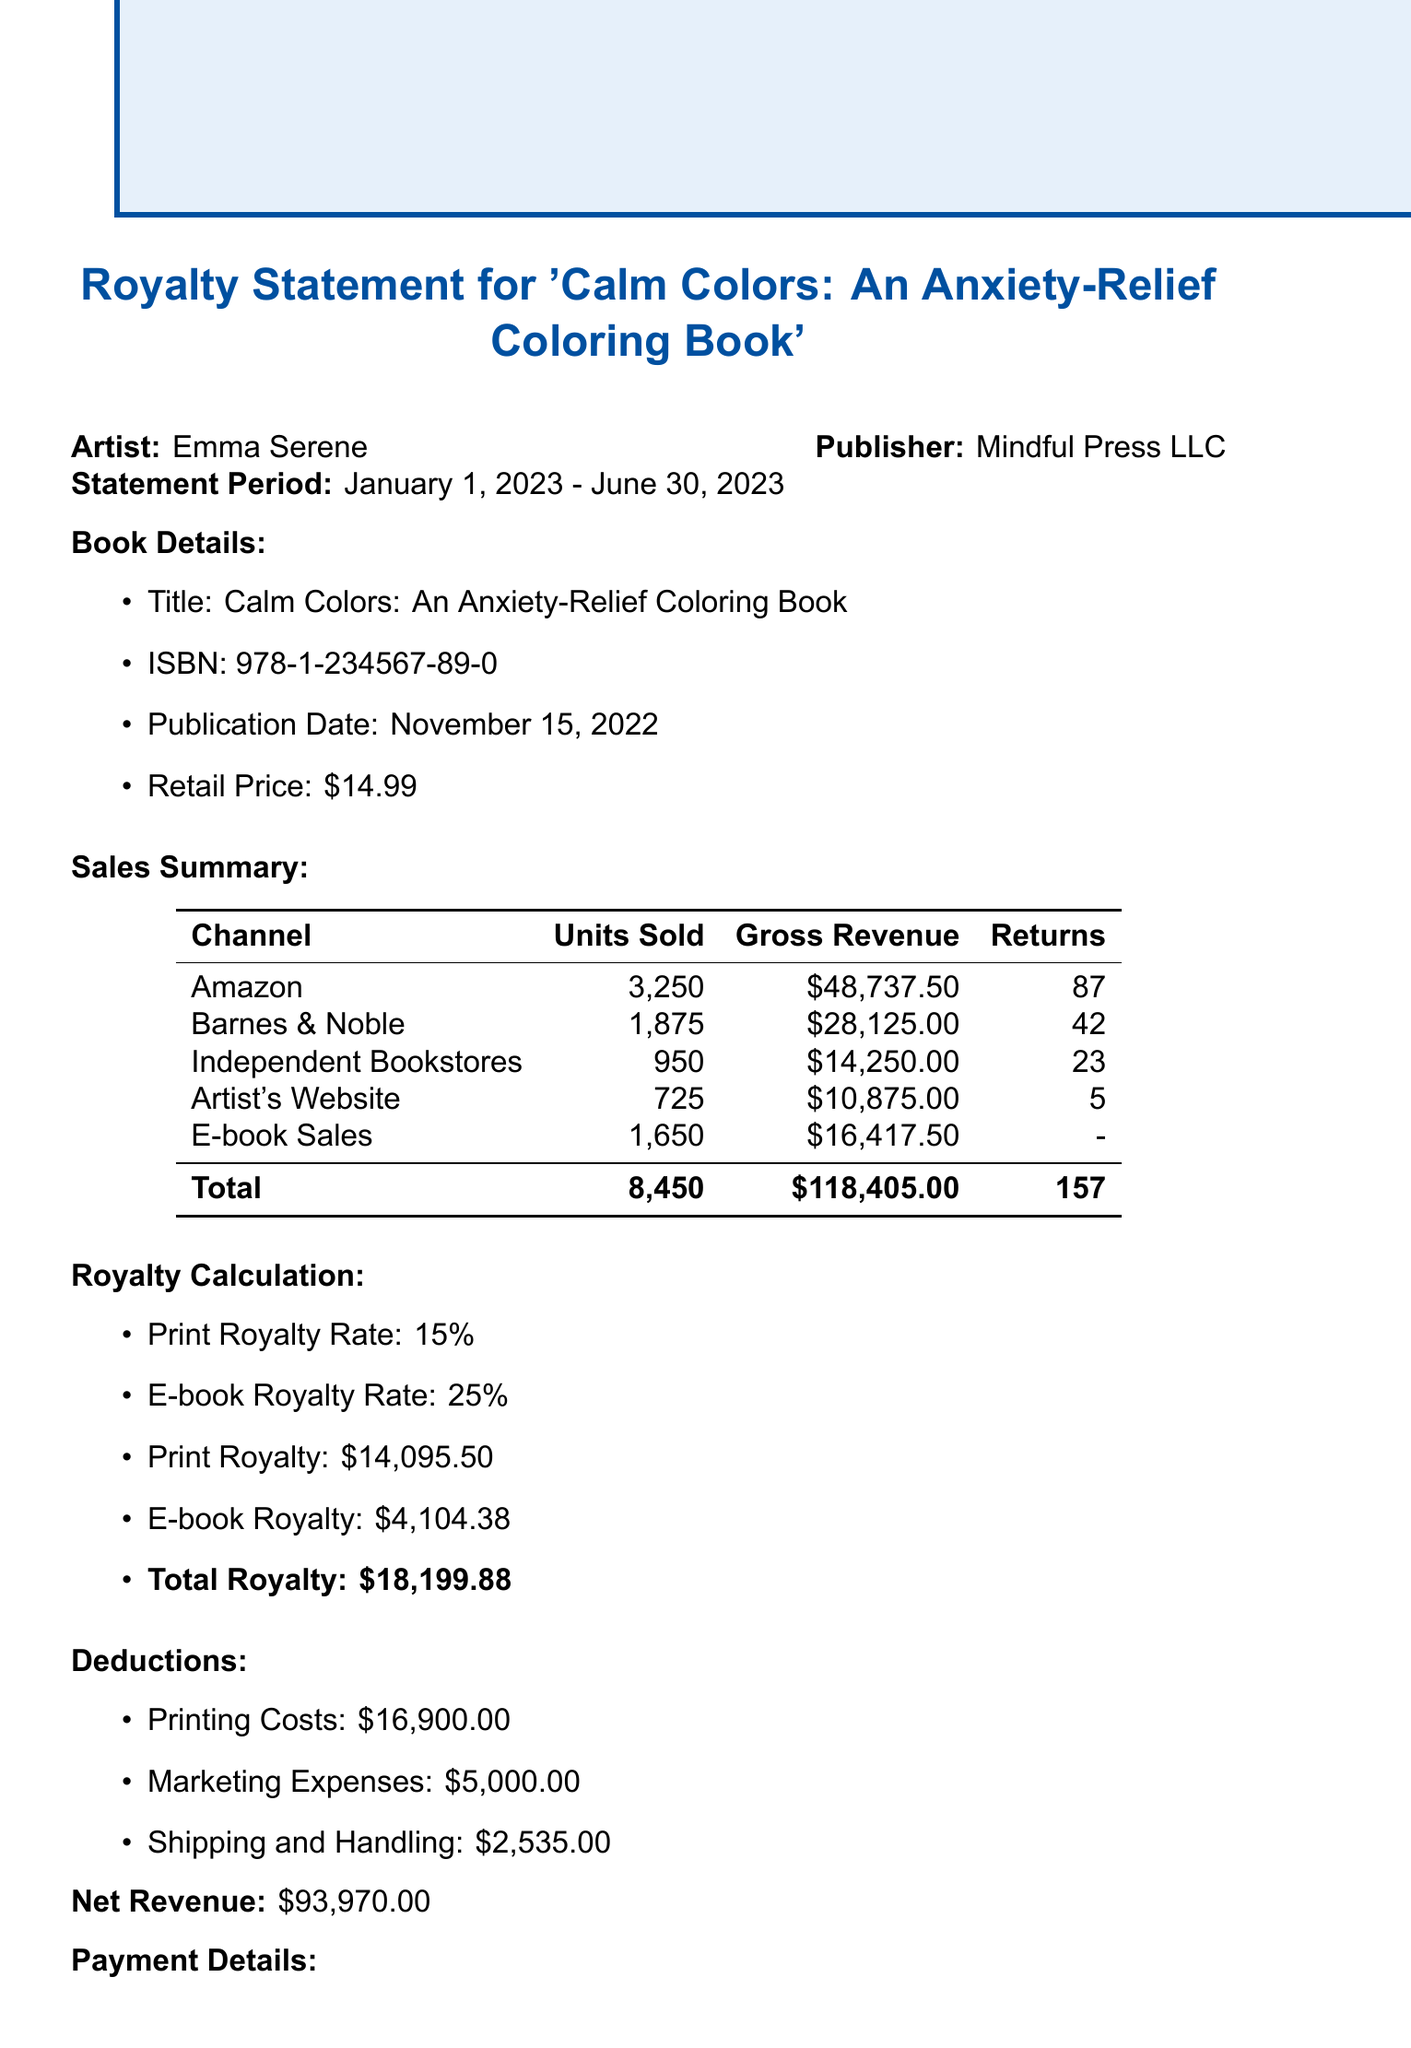what is the artist's name? The artist's name is mentioned at the beginning of the document.
Answer: Emma Serene what is the total units sold? The total units sold is provided in the summary section of the document.
Answer: 8450 what is the payment date? The payment date is specifically outlined in the payment details section.
Answer: July 15, 2023 how much were the printing costs? The printing costs are listed under the deductions section of the document.
Answer: $16,900.00 what is the gross revenue from ebook sales? The gross revenue from ebook sales is detailed in the ebook sales section.
Answer: $16,417.50 what was the royalty rate for print sales? The royalty rate for print sales is specified in the royalty calculation section.
Answer: 15% how many units were sold through Amazon? The units sold through Amazon are recorded in the sales summary section.
Answer: 3250 what is the net revenue? The net revenue is calculated after all deductions and is provided in the document.
Answer: $93,970.00 who is the contact person for royalties? The contact person for royalties is listed towards the end of the document.
Answer: Sarah Thompson 